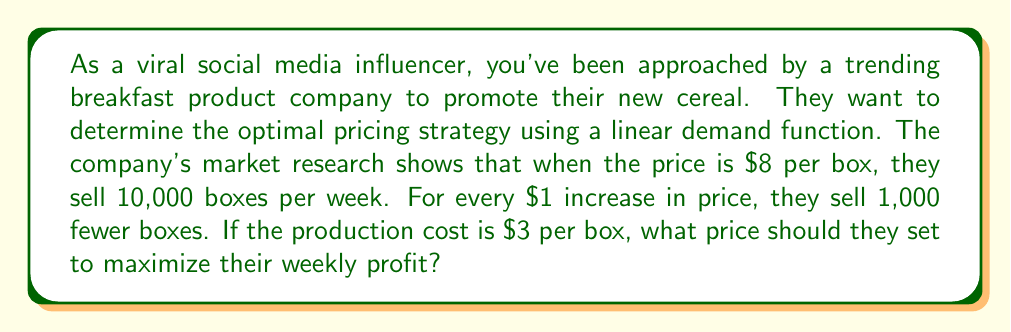Show me your answer to this math problem. Let's approach this step-by-step:

1) First, let's define our variables:
   $p$ = price per box
   $q$ = quantity of boxes sold per week

2) We can express the demand function as:
   $q = 18000 - 1000p$

3) The revenue function is price times quantity:
   $R = pq = p(18000 - 1000p) = 18000p - 1000p^2$

4) The cost function, given $\$3$ production cost per box:
   $C = 3q = 3(18000 - 1000p) = 54000 - 3000p$

5) The profit function is revenue minus cost:
   $$\begin{align}
   P &= R - C \\
   &= (18000p - 1000p^2) - (54000 - 3000p) \\
   &= 18000p - 1000p^2 - 54000 + 3000p \\
   &= -1000p^2 + 21000p - 54000
   \end{align}$$

6) To find the maximum profit, we differentiate $P$ with respect to $p$ and set it to zero:
   $$\begin{align}
   \frac{dP}{dp} &= -2000p + 21000 = 0 \\
   2000p &= 21000 \\
   p &= 10.5
   \end{align}$$

7) To confirm this is a maximum, we can check the second derivative is negative:
   $\frac{d^2P}{dp^2} = -2000 < 0$

Therefore, the profit-maximizing price is $\$10.50$ per box.
Answer: $\$10.50$ per box 